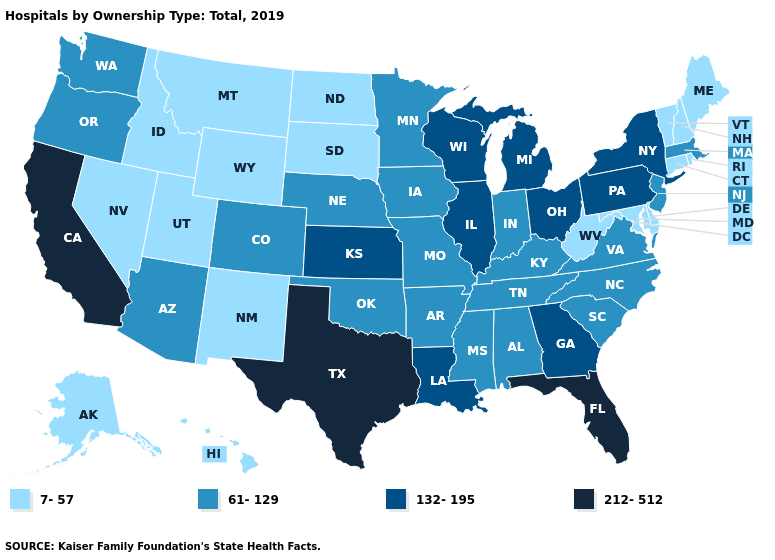Does Iowa have the lowest value in the USA?
Quick response, please. No. Does Massachusetts have the lowest value in the Northeast?
Answer briefly. No. Which states have the lowest value in the USA?
Keep it brief. Alaska, Connecticut, Delaware, Hawaii, Idaho, Maine, Maryland, Montana, Nevada, New Hampshire, New Mexico, North Dakota, Rhode Island, South Dakota, Utah, Vermont, West Virginia, Wyoming. What is the lowest value in the West?
Answer briefly. 7-57. Does Alaska have the lowest value in the USA?
Be succinct. Yes. Name the states that have a value in the range 61-129?
Write a very short answer. Alabama, Arizona, Arkansas, Colorado, Indiana, Iowa, Kentucky, Massachusetts, Minnesota, Mississippi, Missouri, Nebraska, New Jersey, North Carolina, Oklahoma, Oregon, South Carolina, Tennessee, Virginia, Washington. What is the highest value in states that border Vermont?
Write a very short answer. 132-195. Does Arkansas have the lowest value in the USA?
Give a very brief answer. No. What is the value of Utah?
Short answer required. 7-57. Among the states that border Minnesota , does Wisconsin have the lowest value?
Give a very brief answer. No. Name the states that have a value in the range 132-195?
Write a very short answer. Georgia, Illinois, Kansas, Louisiana, Michigan, New York, Ohio, Pennsylvania, Wisconsin. Name the states that have a value in the range 7-57?
Give a very brief answer. Alaska, Connecticut, Delaware, Hawaii, Idaho, Maine, Maryland, Montana, Nevada, New Hampshire, New Mexico, North Dakota, Rhode Island, South Dakota, Utah, Vermont, West Virginia, Wyoming. Which states have the lowest value in the USA?
Keep it brief. Alaska, Connecticut, Delaware, Hawaii, Idaho, Maine, Maryland, Montana, Nevada, New Hampshire, New Mexico, North Dakota, Rhode Island, South Dakota, Utah, Vermont, West Virginia, Wyoming. Does the first symbol in the legend represent the smallest category?
Concise answer only. Yes. Does Maryland have the lowest value in the South?
Quick response, please. Yes. 